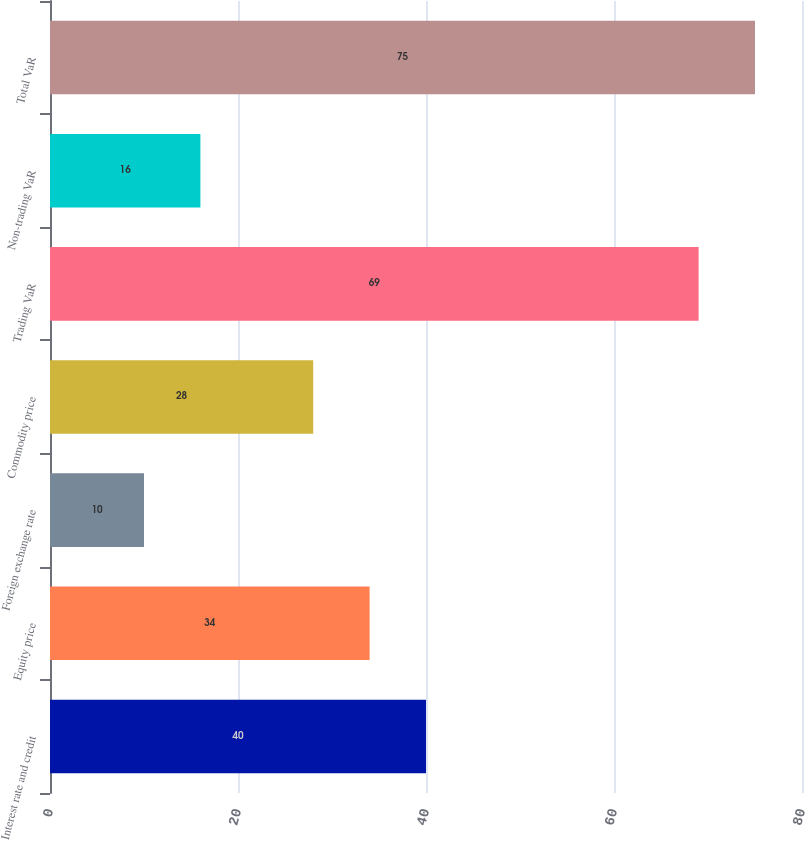Convert chart to OTSL. <chart><loc_0><loc_0><loc_500><loc_500><bar_chart><fcel>Interest rate and credit<fcel>Equity price<fcel>Foreign exchange rate<fcel>Commodity price<fcel>Trading VaR<fcel>Non-trading VaR<fcel>Total VaR<nl><fcel>40<fcel>34<fcel>10<fcel>28<fcel>69<fcel>16<fcel>75<nl></chart> 